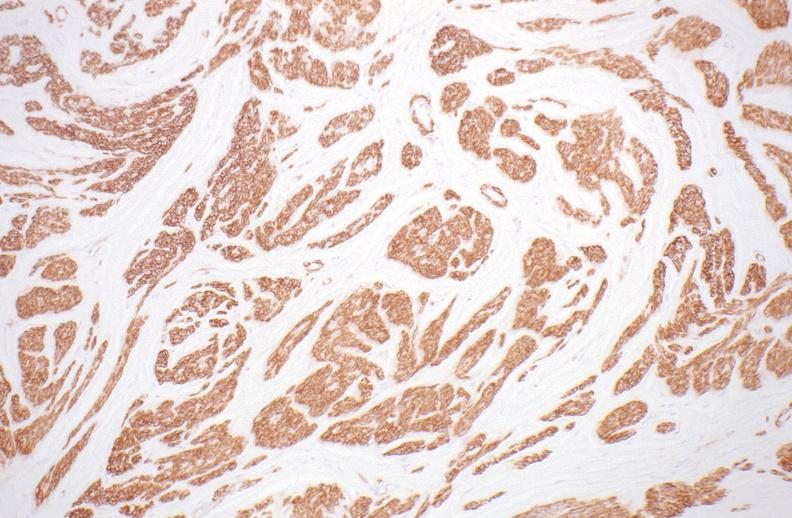what does this image show?
Answer the question using a single word or phrase. Leiomyoma 